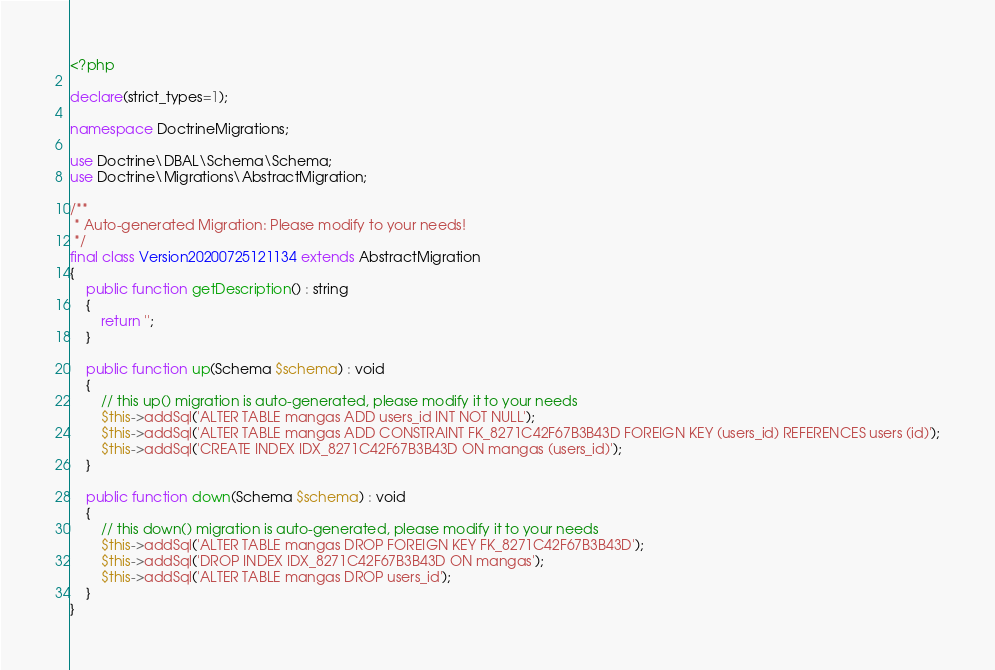Convert code to text. <code><loc_0><loc_0><loc_500><loc_500><_PHP_><?php

declare(strict_types=1);

namespace DoctrineMigrations;

use Doctrine\DBAL\Schema\Schema;
use Doctrine\Migrations\AbstractMigration;

/**
 * Auto-generated Migration: Please modify to your needs!
 */
final class Version20200725121134 extends AbstractMigration
{
    public function getDescription() : string
    {
        return '';
    }

    public function up(Schema $schema) : void
    {
        // this up() migration is auto-generated, please modify it to your needs
        $this->addSql('ALTER TABLE mangas ADD users_id INT NOT NULL');
        $this->addSql('ALTER TABLE mangas ADD CONSTRAINT FK_8271C42F67B3B43D FOREIGN KEY (users_id) REFERENCES users (id)');
        $this->addSql('CREATE INDEX IDX_8271C42F67B3B43D ON mangas (users_id)');
    }

    public function down(Schema $schema) : void
    {
        // this down() migration is auto-generated, please modify it to your needs
        $this->addSql('ALTER TABLE mangas DROP FOREIGN KEY FK_8271C42F67B3B43D');
        $this->addSql('DROP INDEX IDX_8271C42F67B3B43D ON mangas');
        $this->addSql('ALTER TABLE mangas DROP users_id');
    }
}
</code> 